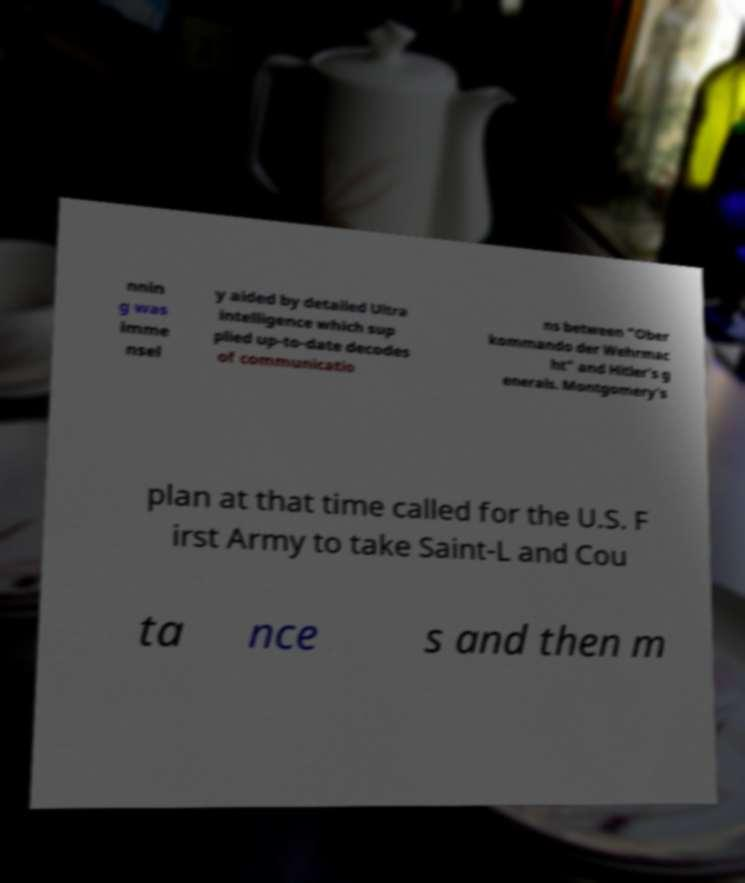Please identify and transcribe the text found in this image. nnin g was imme nsel y aided by detailed Ultra intelligence which sup plied up-to-date decodes of communicatio ns between "Ober kommando der Wehrmac ht" and Hitler's g enerals. Montgomery's plan at that time called for the U.S. F irst Army to take Saint-L and Cou ta nce s and then m 